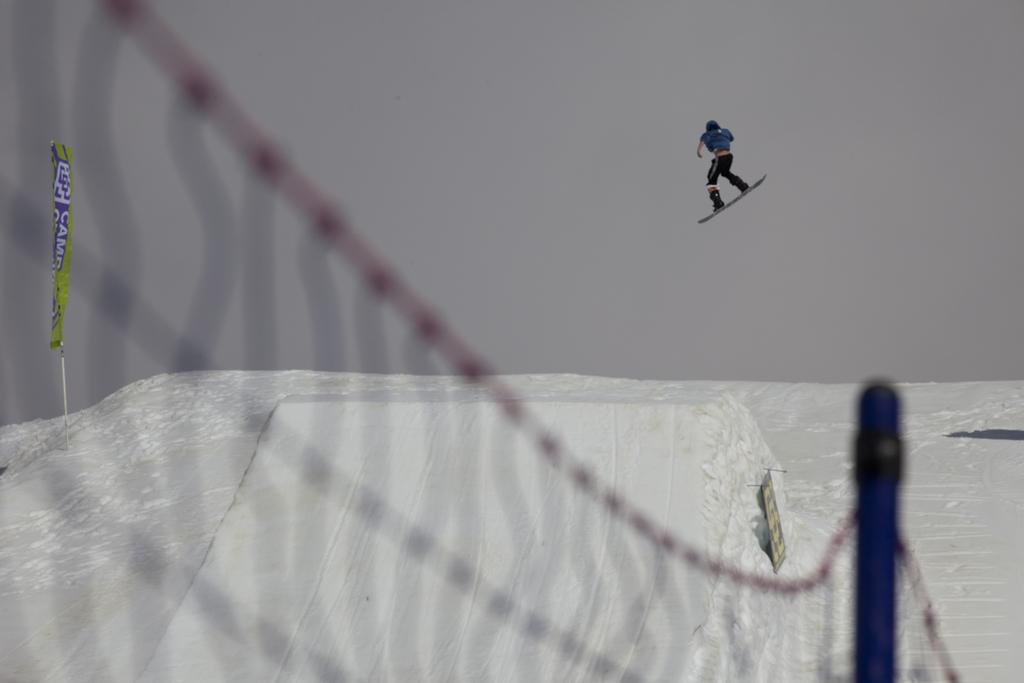Describe this image in one or two sentences. In this image, we can see a person doing skateboarding is in the air. We can also see the ground covered with snow and an object. We can also see some net and a pole. We can also see a banner. We can see the sky. 